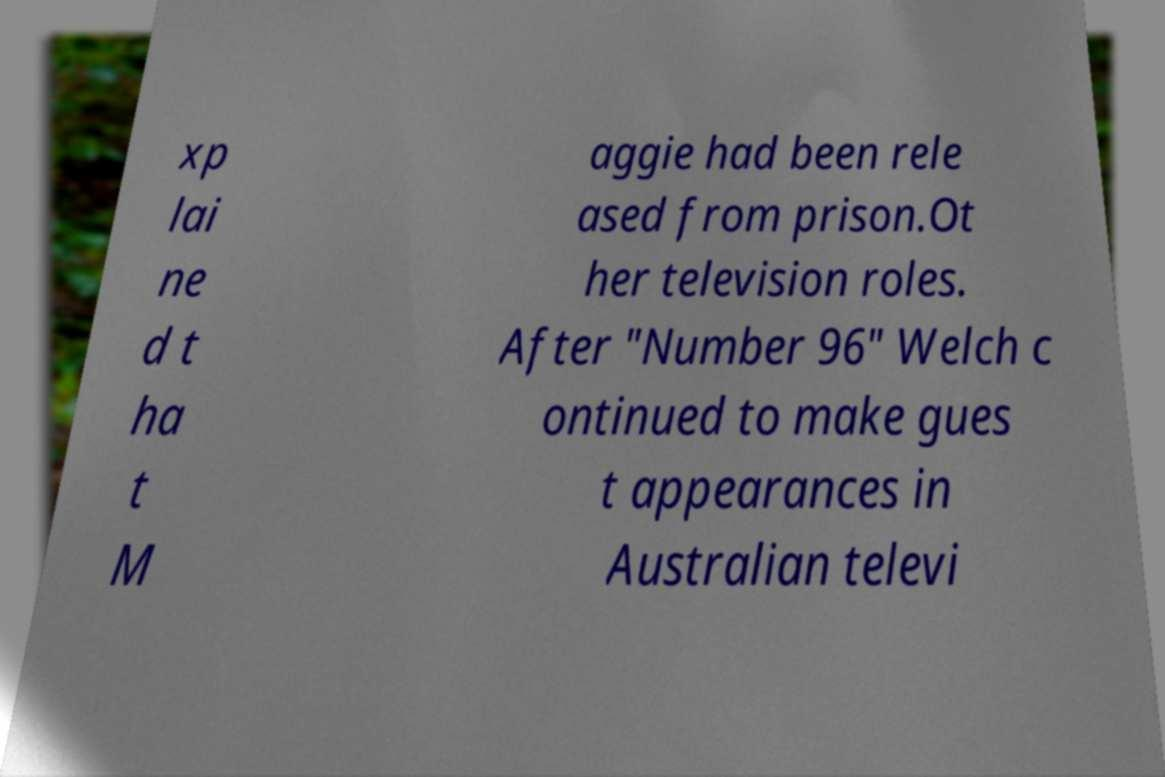Please identify and transcribe the text found in this image. xp lai ne d t ha t M aggie had been rele ased from prison.Ot her television roles. After "Number 96" Welch c ontinued to make gues t appearances in Australian televi 